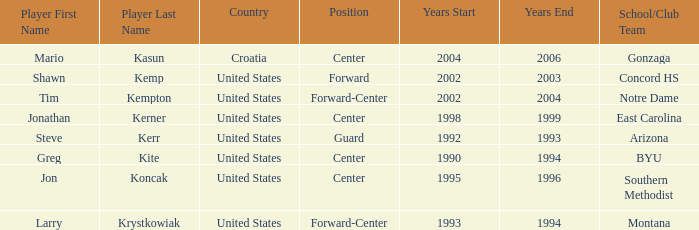What years in orlando have the United States as the nationality, and montana as the school/club team? 1993–1994. 